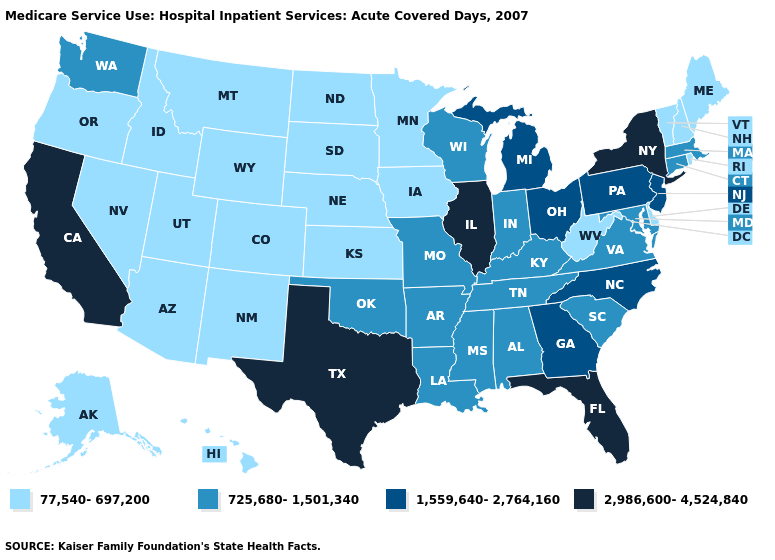Among the states that border Kentucky , does West Virginia have the highest value?
Give a very brief answer. No. What is the value of West Virginia?
Concise answer only. 77,540-697,200. Among the states that border Indiana , does Ohio have the lowest value?
Keep it brief. No. Name the states that have a value in the range 2,986,600-4,524,840?
Be succinct. California, Florida, Illinois, New York, Texas. Which states hav the highest value in the South?
Write a very short answer. Florida, Texas. Does Vermont have the lowest value in the USA?
Quick response, please. Yes. Does Louisiana have the highest value in the USA?
Answer briefly. No. Name the states that have a value in the range 725,680-1,501,340?
Answer briefly. Alabama, Arkansas, Connecticut, Indiana, Kentucky, Louisiana, Maryland, Massachusetts, Mississippi, Missouri, Oklahoma, South Carolina, Tennessee, Virginia, Washington, Wisconsin. What is the value of Oregon?
Write a very short answer. 77,540-697,200. What is the highest value in the USA?
Answer briefly. 2,986,600-4,524,840. What is the value of Wisconsin?
Quick response, please. 725,680-1,501,340. What is the value of West Virginia?
Quick response, please. 77,540-697,200. Among the states that border Nebraska , does Wyoming have the lowest value?
Give a very brief answer. Yes. What is the lowest value in states that border Virginia?
Quick response, please. 77,540-697,200. Does South Carolina have the highest value in the USA?
Keep it brief. No. 